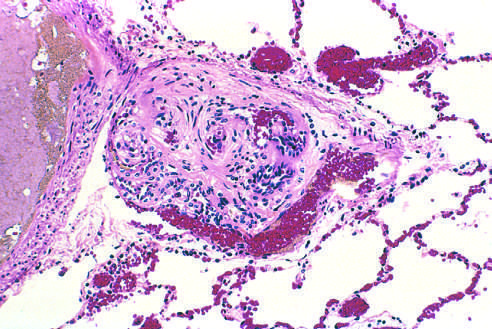s hematoxylin-eosin seen in small arteries?
Answer the question using a single word or phrase. No 